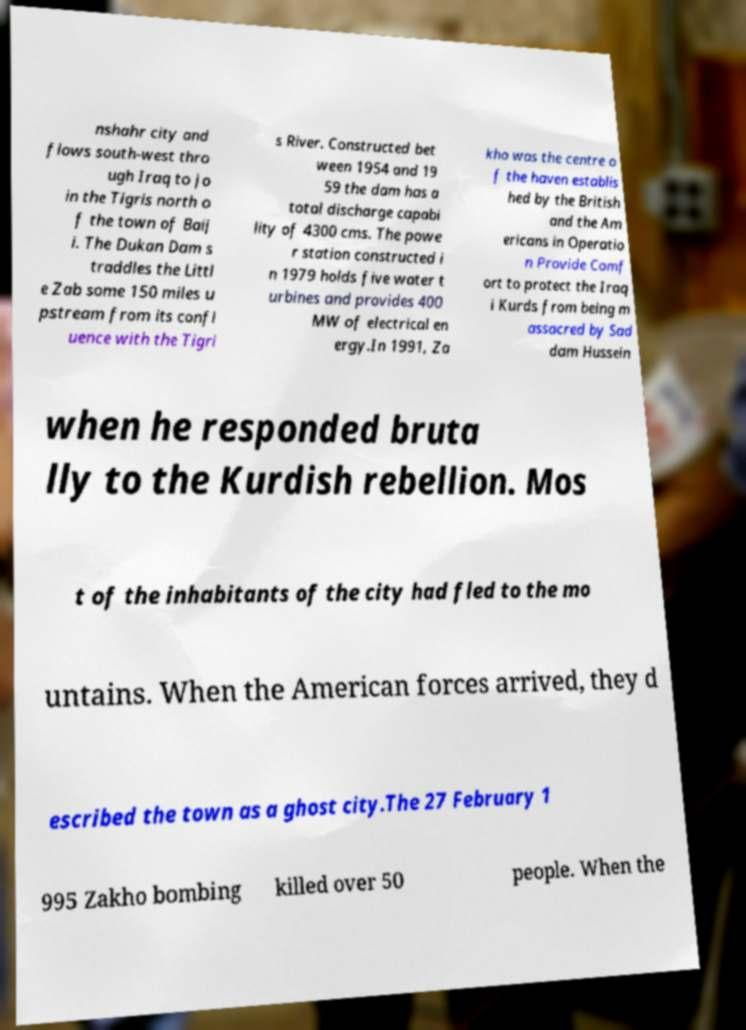For documentation purposes, I need the text within this image transcribed. Could you provide that? nshahr city and flows south-west thro ugh Iraq to jo in the Tigris north o f the town of Baij i. The Dukan Dam s traddles the Littl e Zab some 150 miles u pstream from its confl uence with the Tigri s River. Constructed bet ween 1954 and 19 59 the dam has a total discharge capabi lity of 4300 cms. The powe r station constructed i n 1979 holds five water t urbines and provides 400 MW of electrical en ergy.In 1991, Za kho was the centre o f the haven establis hed by the British and the Am ericans in Operatio n Provide Comf ort to protect the Iraq i Kurds from being m assacred by Sad dam Hussein when he responded bruta lly to the Kurdish rebellion. Mos t of the inhabitants of the city had fled to the mo untains. When the American forces arrived, they d escribed the town as a ghost city.The 27 February 1 995 Zakho bombing killed over 50 people. When the 